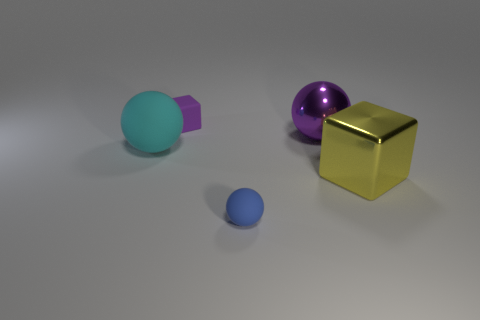Can you describe the texture and likely physical properties of the items based on their appearance? Sure, the surfaces of the objects appear smooth; the cyan and blue spheres, along with the purple object, look like they might be slightly soft to the touch, suggesting a rubbery material. In contrast, the gold cube seems hard and rigid, with a reflective surface that implies a metal construction, suggesting a heavier and more solid material. 